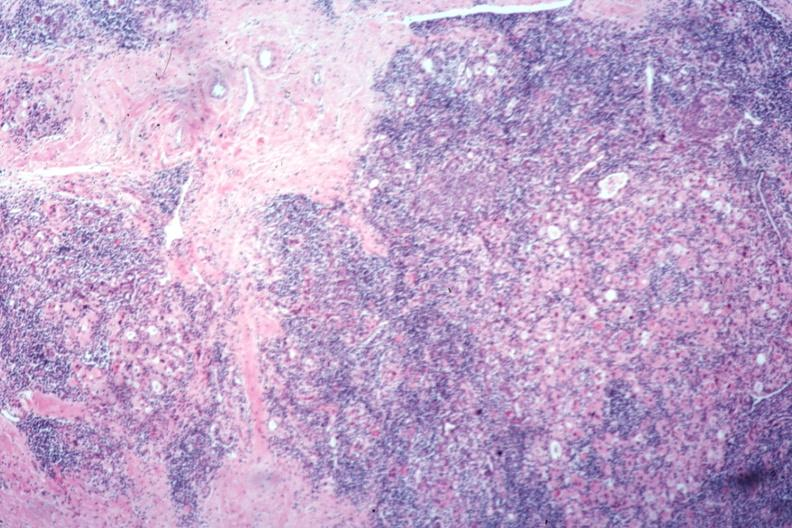what is present?
Answer the question using a single word or phrase. Endocrine 